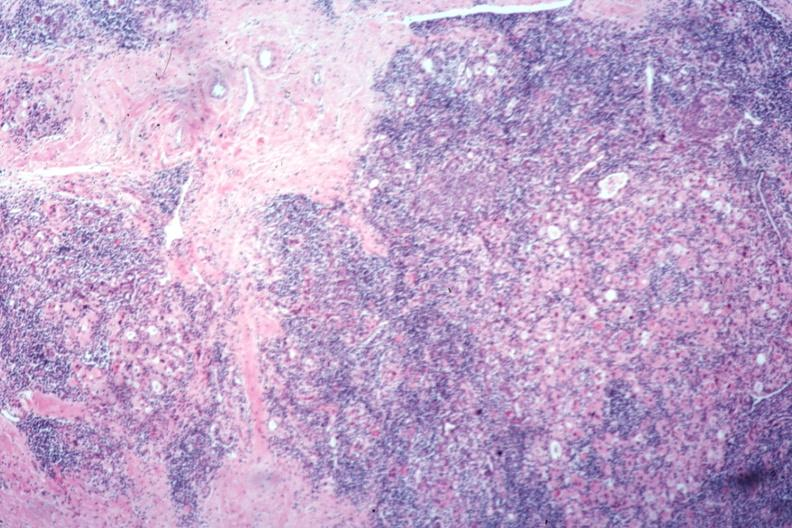what is present?
Answer the question using a single word or phrase. Endocrine 